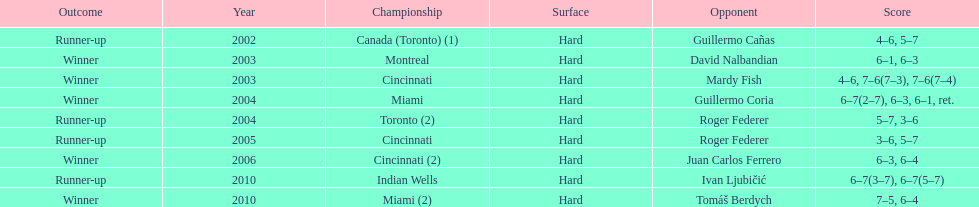Was roddick a runner-up or winner more? Winner. 